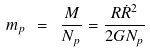Convert formula to latex. <formula><loc_0><loc_0><loc_500><loc_500>m _ { p } \ = \ \frac { M } { N _ { p } } = \frac { R { \dot { R } } ^ { 2 } } { 2 G N _ { p } }</formula> 